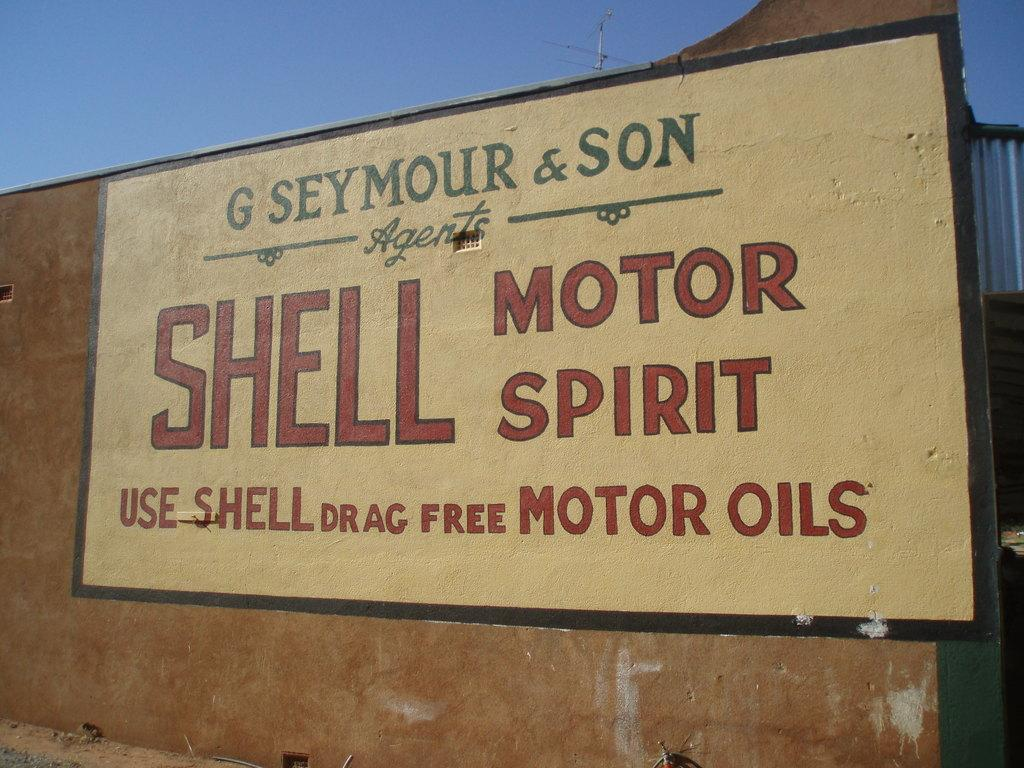<image>
Write a terse but informative summary of the picture. Shell Motor Spirit that is Drag Free Motor Oils. 